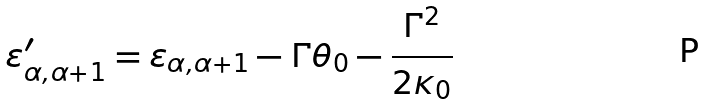Convert formula to latex. <formula><loc_0><loc_0><loc_500><loc_500>\varepsilon _ { \alpha , \alpha + 1 } ^ { \prime } = \varepsilon _ { \alpha , \alpha + 1 } - \Gamma \theta _ { 0 } - \frac { \Gamma ^ { 2 } } { 2 \kappa _ { 0 } }</formula> 